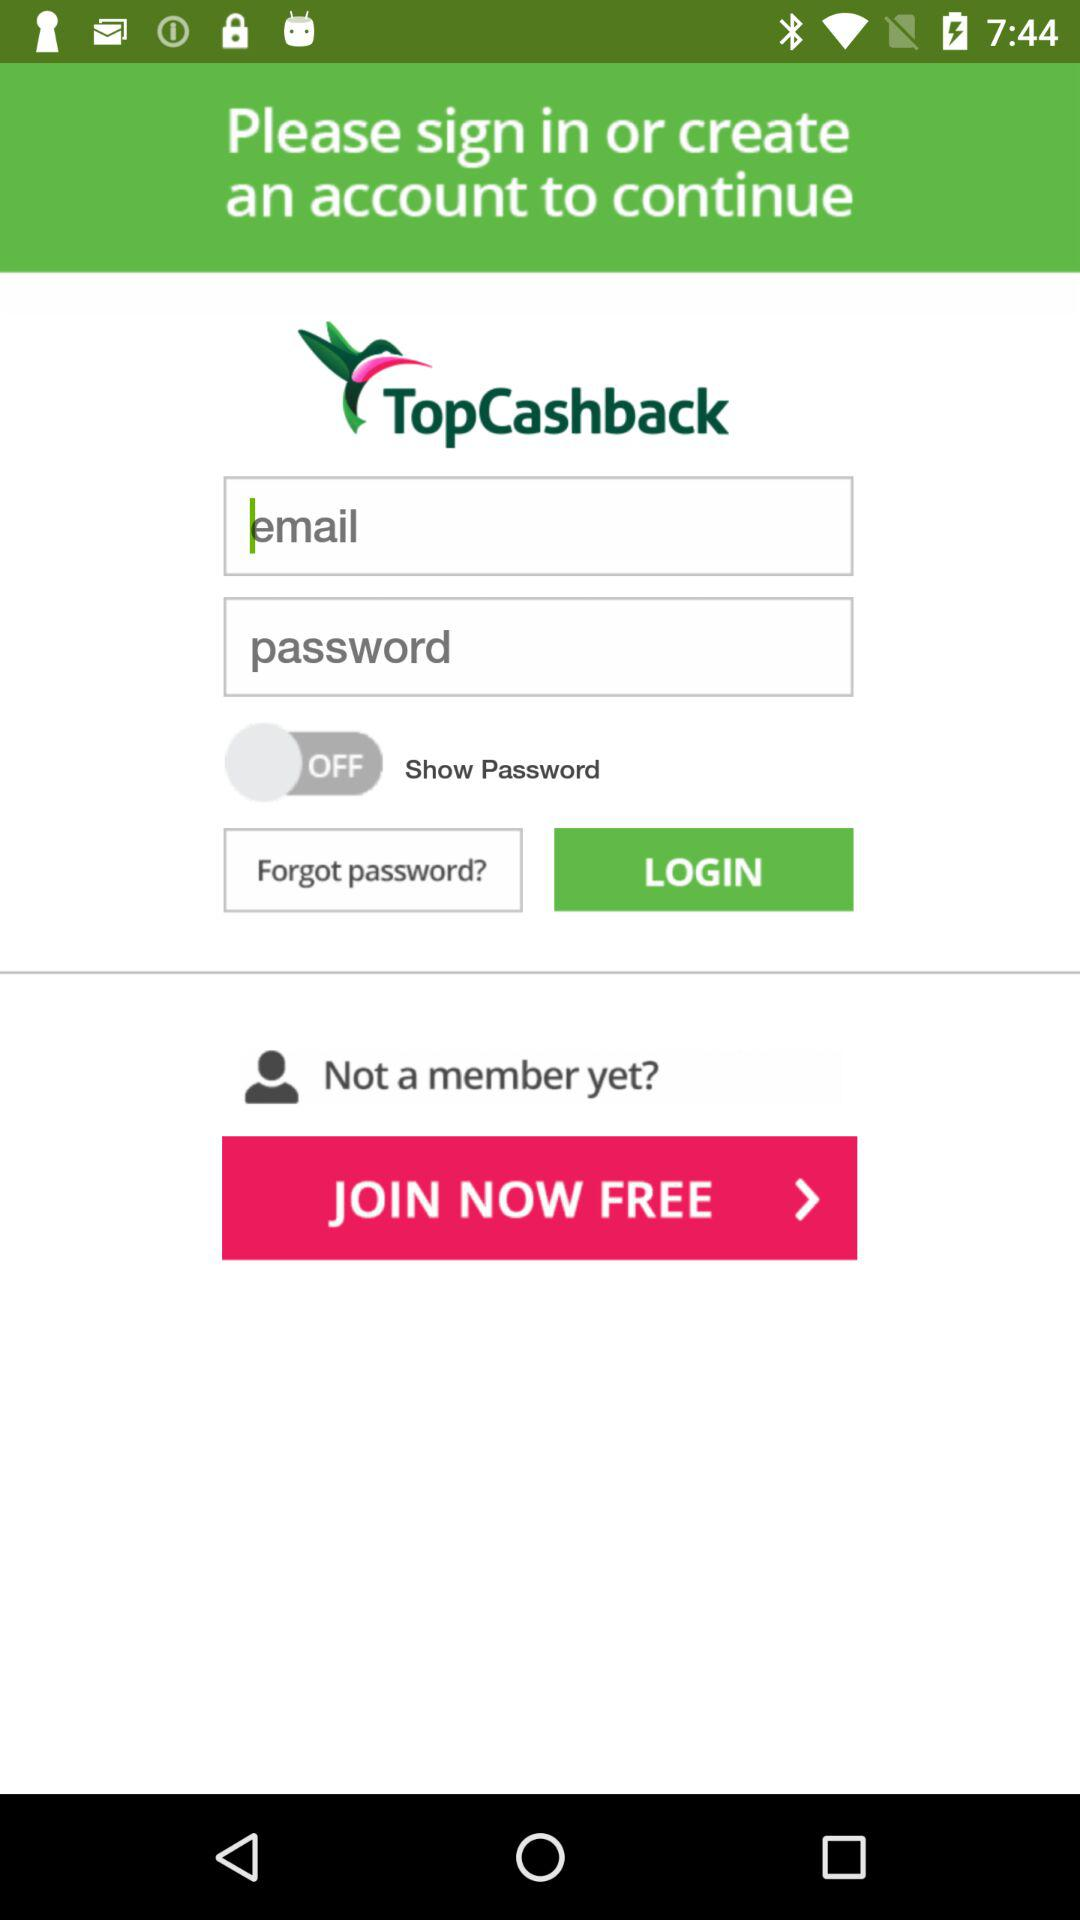What is the name of the application? The name of the application is "TopCashback". 